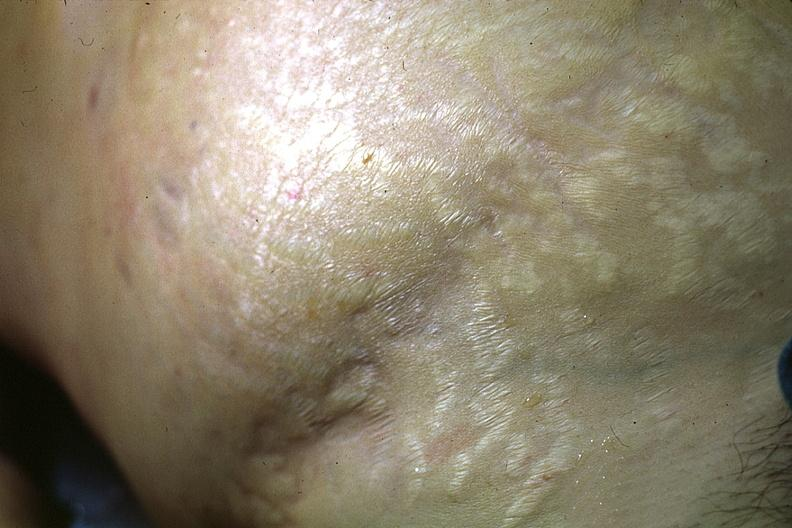where is this?
Answer the question using a single word or phrase. Skin 